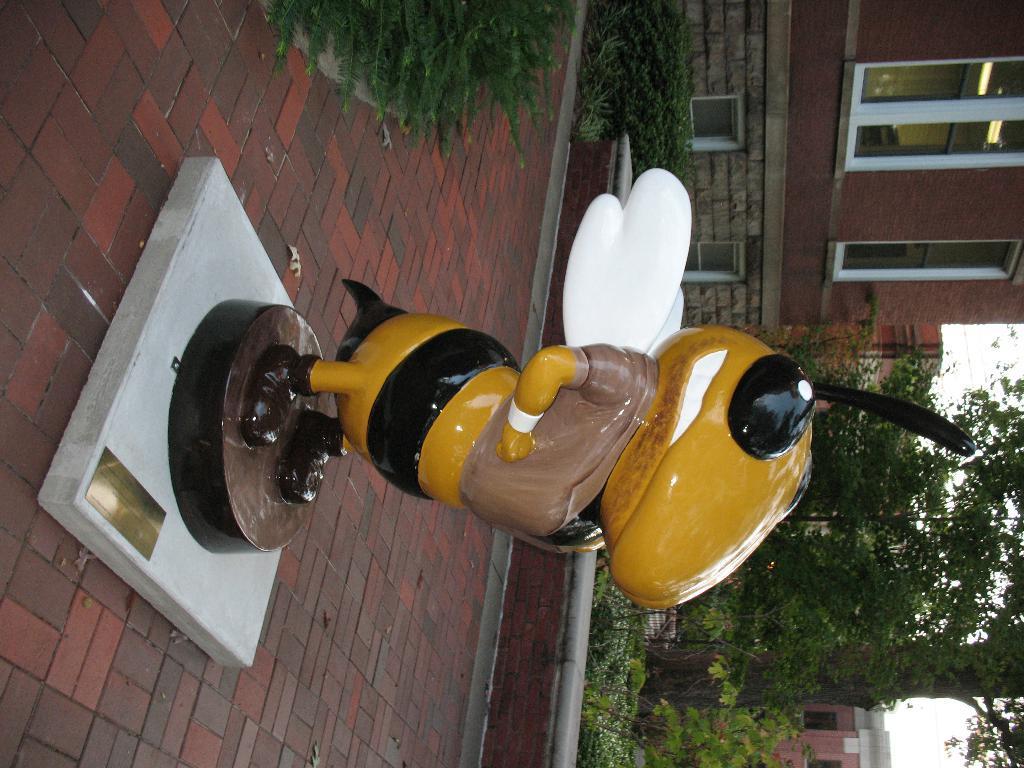Please provide a concise description of this image. In the middle of the picture there is a sculpture of a honey bee. On the right there are trees and buildings. On the left it is pavement. At the top there are plants. 